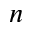Convert formula to latex. <formula><loc_0><loc_0><loc_500><loc_500>n</formula> 